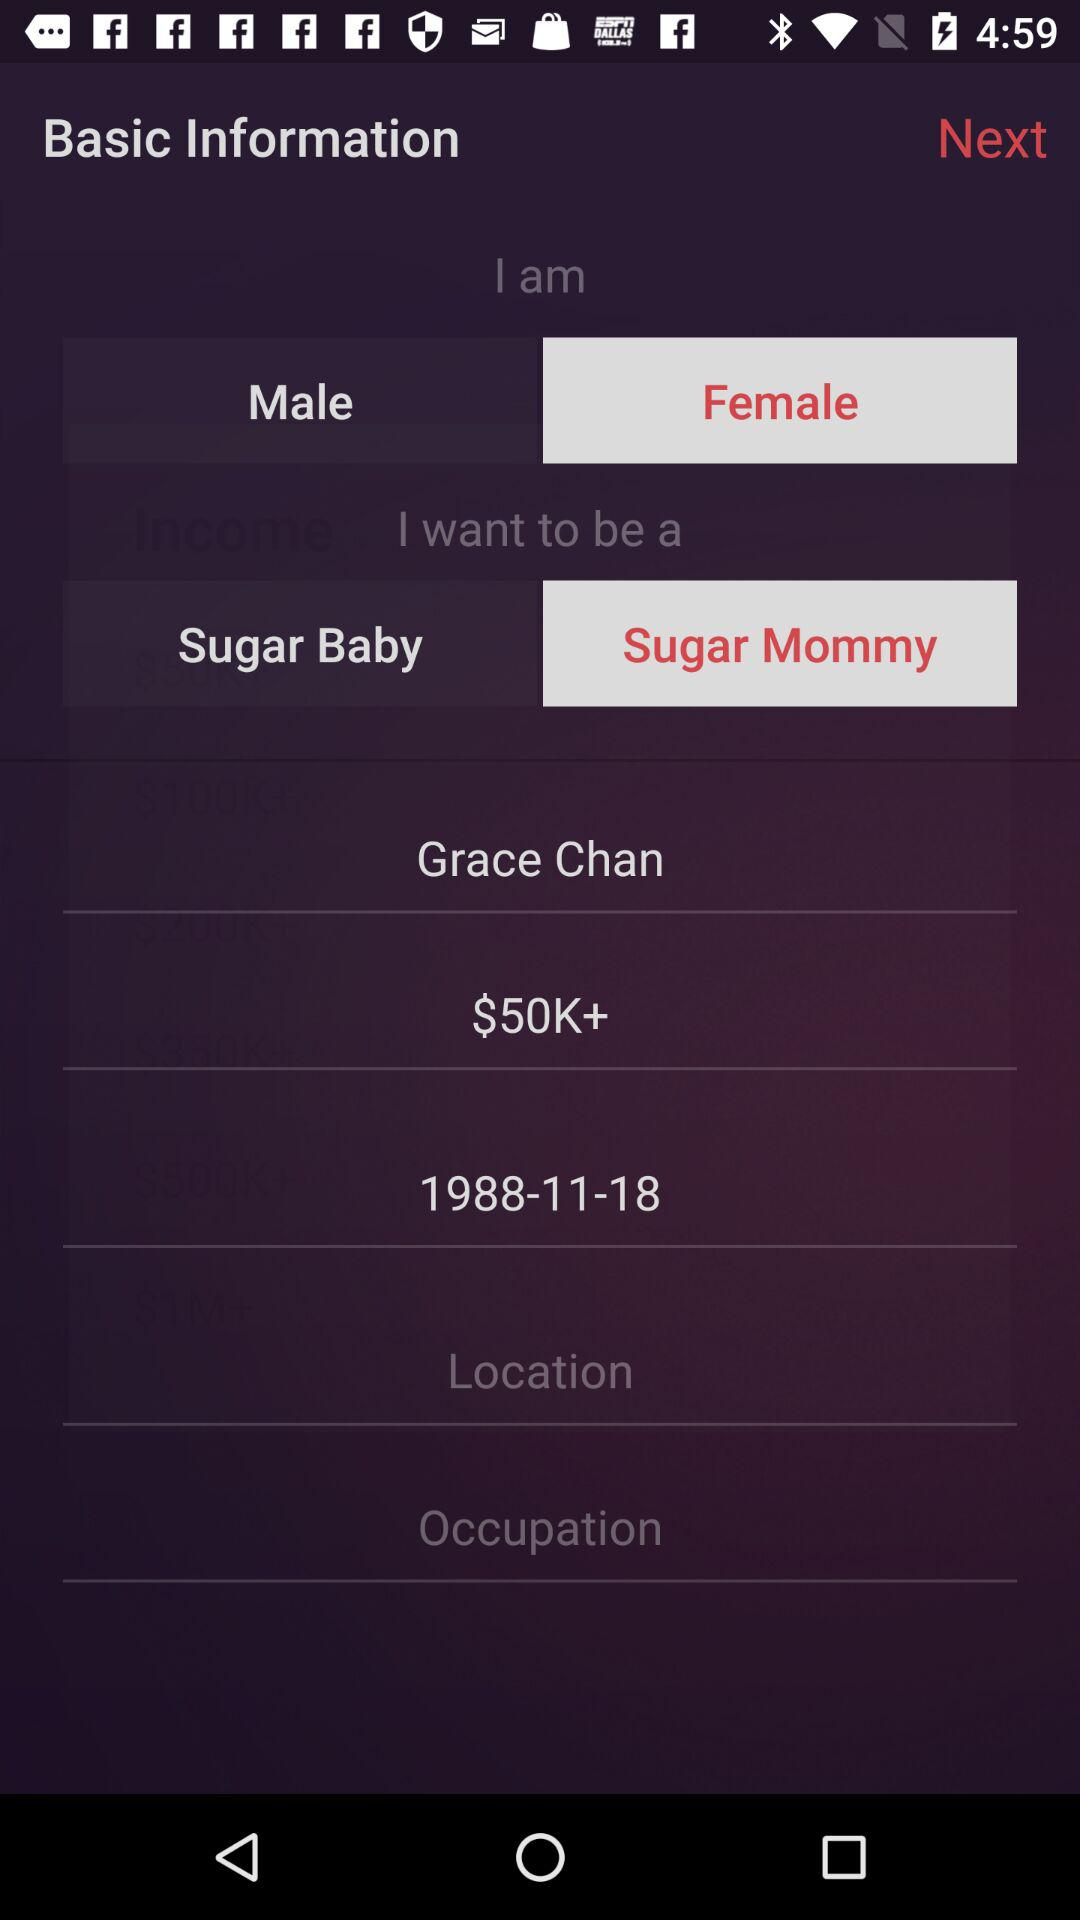What is the mentioned amount? The mentioned amount is $50K+. 